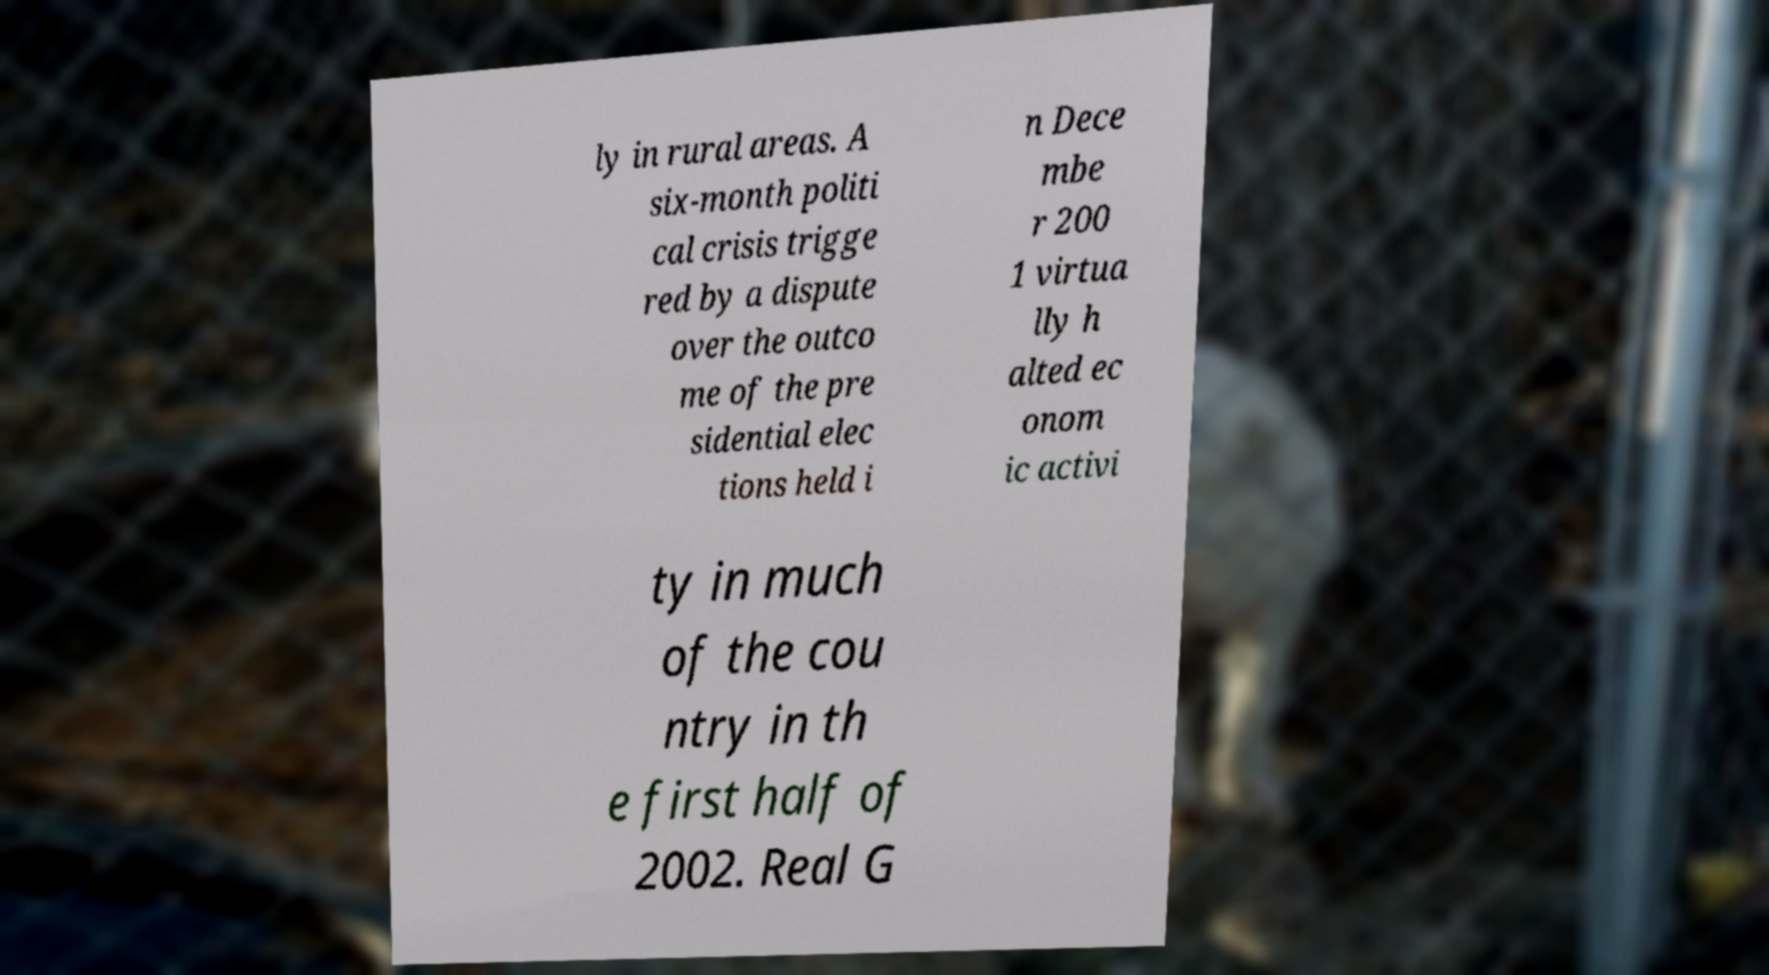What messages or text are displayed in this image? I need them in a readable, typed format. ly in rural areas. A six-month politi cal crisis trigge red by a dispute over the outco me of the pre sidential elec tions held i n Dece mbe r 200 1 virtua lly h alted ec onom ic activi ty in much of the cou ntry in th e first half of 2002. Real G 